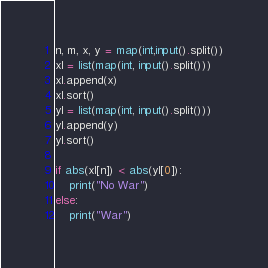Convert code to text. <code><loc_0><loc_0><loc_500><loc_500><_Python_>n, m, x, y = map(int,input().split())
xl = list(map(int, input().split()))
xl.append(x)
xl.sort()
yl = list(map(int, input().split()))
yl.append(y)
yl.sort()

if abs(xl[n]) < abs(yl[0]):
    print("No War")
else:
    print("War")
</code> 